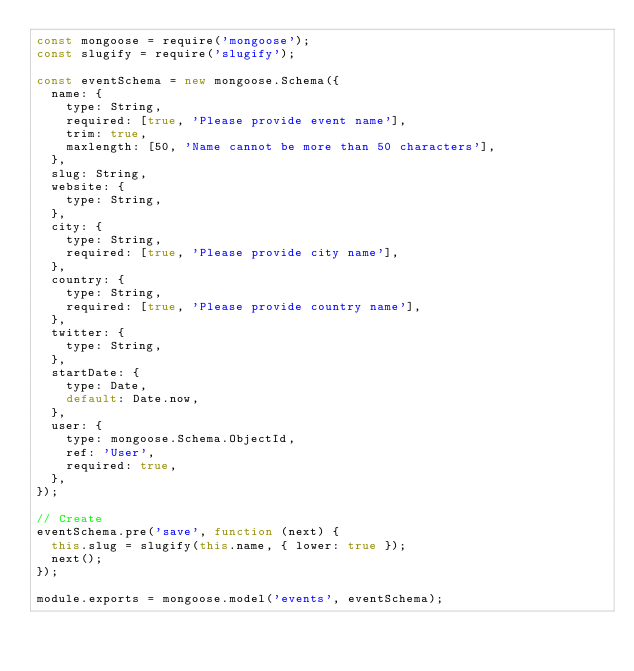<code> <loc_0><loc_0><loc_500><loc_500><_JavaScript_>const mongoose = require('mongoose');
const slugify = require('slugify');

const eventSchema = new mongoose.Schema({
  name: {
    type: String,
    required: [true, 'Please provide event name'],
    trim: true,
    maxlength: [50, 'Name cannot be more than 50 characters'],
  },
  slug: String,
  website: {
    type: String,
  },
  city: {
    type: String,
    required: [true, 'Please provide city name'],
  },
  country: {
    type: String,
    required: [true, 'Please provide country name'],
  },
  twitter: {
    type: String,
  },
  startDate: {
    type: Date,
    default: Date.now,
  },
  user: {
    type: mongoose.Schema.ObjectId,
    ref: 'User',
    required: true,
  },
});

// Create
eventSchema.pre('save', function (next) {
  this.slug = slugify(this.name, { lower: true });
  next();
});

module.exports = mongoose.model('events', eventSchema);
</code> 